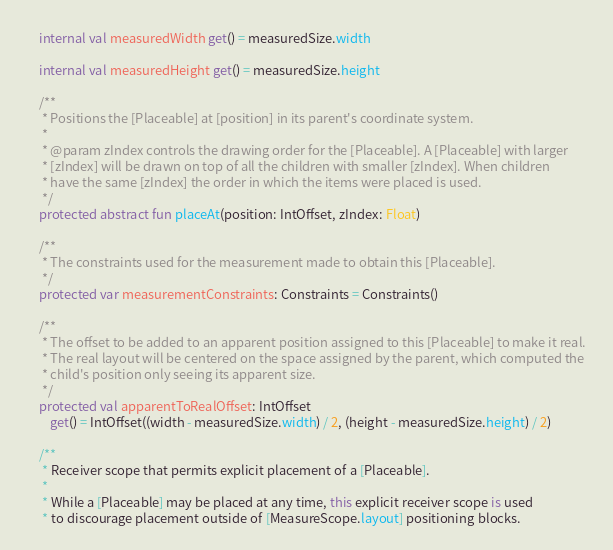<code> <loc_0><loc_0><loc_500><loc_500><_Kotlin_>
    internal val measuredWidth get() = measuredSize.width

    internal val measuredHeight get() = measuredSize.height

    /**
     * Positions the [Placeable] at [position] in its parent's coordinate system.
     *
     * @param zIndex controls the drawing order for the [Placeable]. A [Placeable] with larger
     * [zIndex] will be drawn on top of all the children with smaller [zIndex]. When children
     * have the same [zIndex] the order in which the items were placed is used.
     */
    protected abstract fun placeAt(position: IntOffset, zIndex: Float)

    /**
     * The constraints used for the measurement made to obtain this [Placeable].
     */
    protected var measurementConstraints: Constraints = Constraints()

    /**
     * The offset to be added to an apparent position assigned to this [Placeable] to make it real.
     * The real layout will be centered on the space assigned by the parent, which computed the
     * child's position only seeing its apparent size.
     */
    protected val apparentToRealOffset: IntOffset
        get() = IntOffset((width - measuredSize.width) / 2, (height - measuredSize.height) / 2)

    /**
     * Receiver scope that permits explicit placement of a [Placeable].
     *
     * While a [Placeable] may be placed at any time, this explicit receiver scope is used
     * to discourage placement outside of [MeasureScope.layout] positioning blocks.</code> 